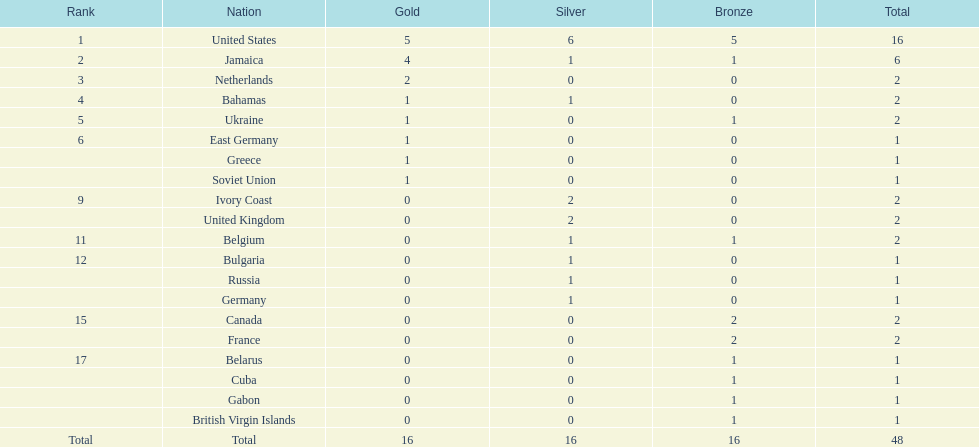What is the average number of gold medals won by the top 5 nations? 2.6. 